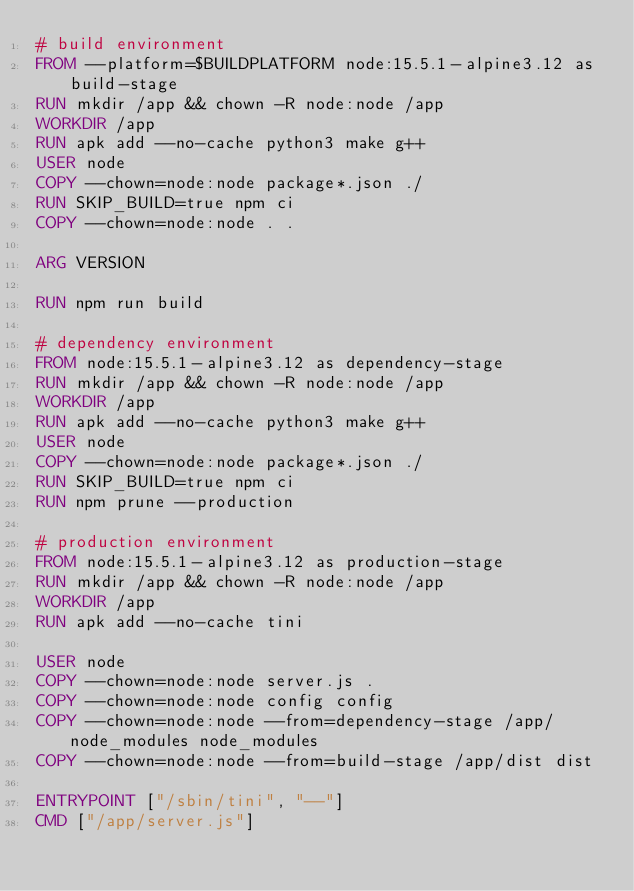<code> <loc_0><loc_0><loc_500><loc_500><_Dockerfile_># build environment
FROM --platform=$BUILDPLATFORM node:15.5.1-alpine3.12 as build-stage
RUN mkdir /app && chown -R node:node /app
WORKDIR /app
RUN apk add --no-cache python3 make g++
USER node
COPY --chown=node:node package*.json ./
RUN SKIP_BUILD=true npm ci
COPY --chown=node:node . .

ARG VERSION

RUN npm run build

# dependency environment
FROM node:15.5.1-alpine3.12 as dependency-stage
RUN mkdir /app && chown -R node:node /app
WORKDIR /app
RUN apk add --no-cache python3 make g++
USER node
COPY --chown=node:node package*.json ./
RUN SKIP_BUILD=true npm ci
RUN npm prune --production

# production environment
FROM node:15.5.1-alpine3.12 as production-stage
RUN mkdir /app && chown -R node:node /app
WORKDIR /app
RUN apk add --no-cache tini

USER node
COPY --chown=node:node server.js .
COPY --chown=node:node config config
COPY --chown=node:node --from=dependency-stage /app/node_modules node_modules
COPY --chown=node:node --from=build-stage /app/dist dist

ENTRYPOINT ["/sbin/tini", "--"]
CMD ["/app/server.js"]
</code> 